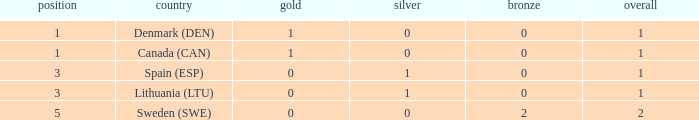How many bronze medals were won when the total is more than 1, and gold is more than 0? None. 